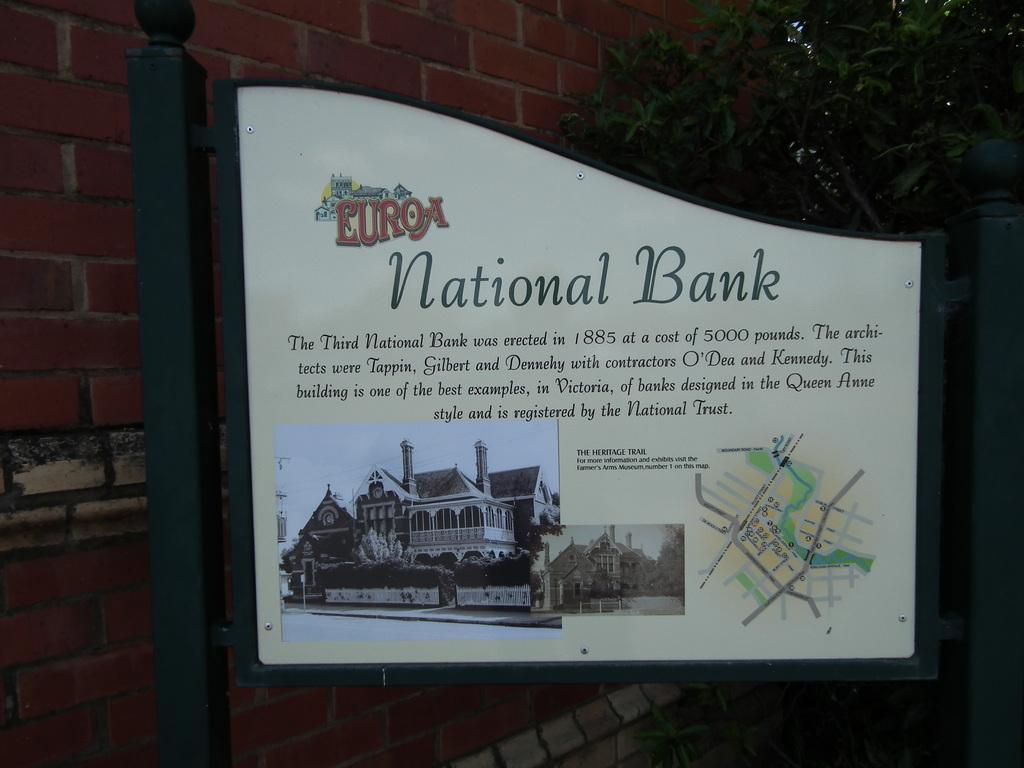When was the third national bank built?
Your answer should be very brief. 1885. What year was the cost of 5000 people?
Make the answer very short. 1885. 